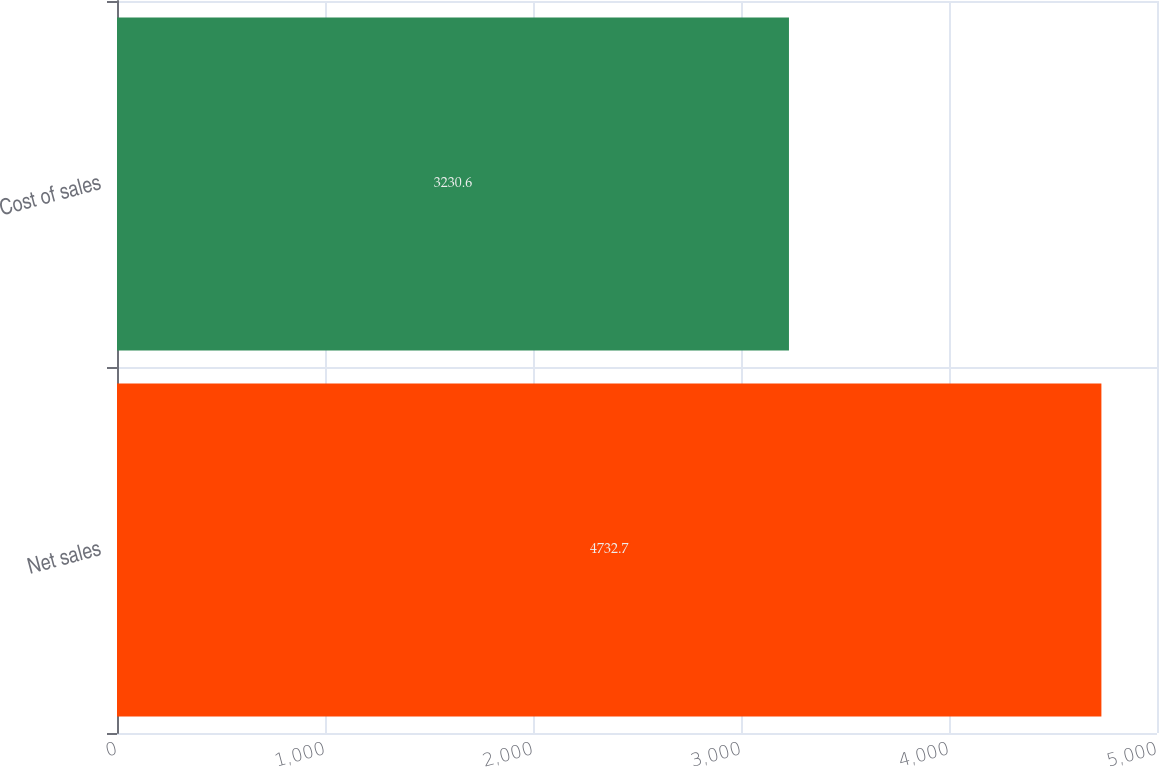Convert chart. <chart><loc_0><loc_0><loc_500><loc_500><bar_chart><fcel>Net sales<fcel>Cost of sales<nl><fcel>4732.7<fcel>3230.6<nl></chart> 